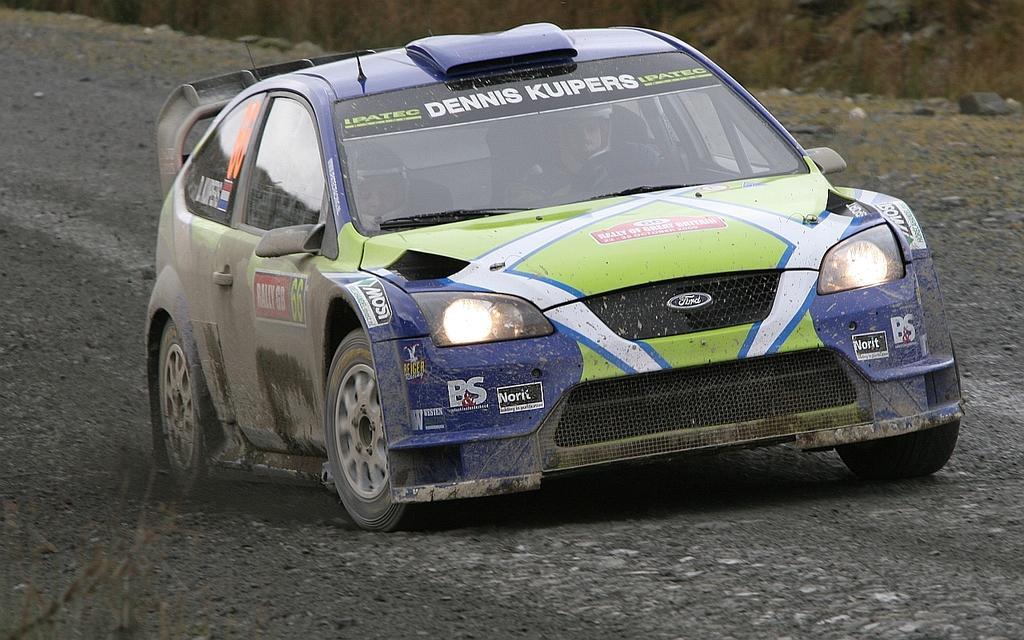In one or two sentences, can you explain what this image depicts? In this image we can see few persons are riding in a car on the ground. In the background we can see stones on the ground. 